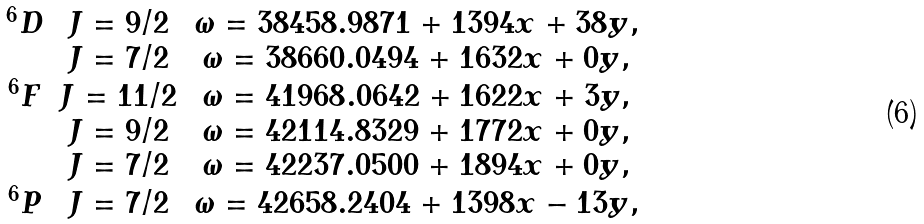<formula> <loc_0><loc_0><loc_500><loc_500>\begin{array} { c c c } ^ { 6 } D & J = 9 / 2 & \omega = 3 8 4 5 8 . 9 8 7 1 + 1 3 9 4 x + 3 8 y , \\ & J = 7 / 2 & \omega = 3 8 6 6 0 . 0 4 9 4 + 1 6 3 2 x + 0 y , \\ ^ { 6 } F & J = 1 1 / 2 & \omega = 4 1 9 6 8 . 0 6 4 2 + 1 6 2 2 x + 3 y , \\ & J = 9 / 2 & \omega = 4 2 1 1 4 . 8 3 2 9 + 1 7 7 2 x + 0 y , \\ & J = 7 / 2 & \omega = 4 2 2 3 7 . 0 5 0 0 + 1 8 9 4 x + 0 y , \\ ^ { 6 } P & J = 7 / 2 & \omega = 4 2 6 5 8 . 2 4 0 4 + 1 3 9 8 x - 1 3 y , \\ \end{array}</formula> 